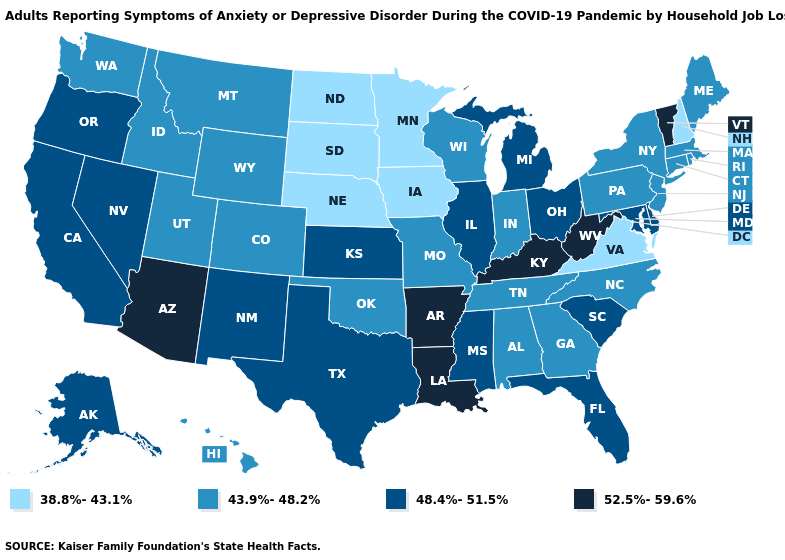What is the value of Georgia?
Short answer required. 43.9%-48.2%. Does the map have missing data?
Give a very brief answer. No. Name the states that have a value in the range 48.4%-51.5%?
Answer briefly. Alaska, California, Delaware, Florida, Illinois, Kansas, Maryland, Michigan, Mississippi, Nevada, New Mexico, Ohio, Oregon, South Carolina, Texas. Name the states that have a value in the range 52.5%-59.6%?
Concise answer only. Arizona, Arkansas, Kentucky, Louisiana, Vermont, West Virginia. Name the states that have a value in the range 43.9%-48.2%?
Quick response, please. Alabama, Colorado, Connecticut, Georgia, Hawaii, Idaho, Indiana, Maine, Massachusetts, Missouri, Montana, New Jersey, New York, North Carolina, Oklahoma, Pennsylvania, Rhode Island, Tennessee, Utah, Washington, Wisconsin, Wyoming. What is the value of Delaware?
Short answer required. 48.4%-51.5%. Does the map have missing data?
Keep it brief. No. Which states have the lowest value in the MidWest?
Write a very short answer. Iowa, Minnesota, Nebraska, North Dakota, South Dakota. What is the highest value in states that border Tennessee?
Write a very short answer. 52.5%-59.6%. Name the states that have a value in the range 48.4%-51.5%?
Write a very short answer. Alaska, California, Delaware, Florida, Illinois, Kansas, Maryland, Michigan, Mississippi, Nevada, New Mexico, Ohio, Oregon, South Carolina, Texas. Which states have the highest value in the USA?
Give a very brief answer. Arizona, Arkansas, Kentucky, Louisiana, Vermont, West Virginia. Name the states that have a value in the range 38.8%-43.1%?
Answer briefly. Iowa, Minnesota, Nebraska, New Hampshire, North Dakota, South Dakota, Virginia. What is the lowest value in the USA?
Quick response, please. 38.8%-43.1%. Which states have the lowest value in the West?
Keep it brief. Colorado, Hawaii, Idaho, Montana, Utah, Washington, Wyoming. 